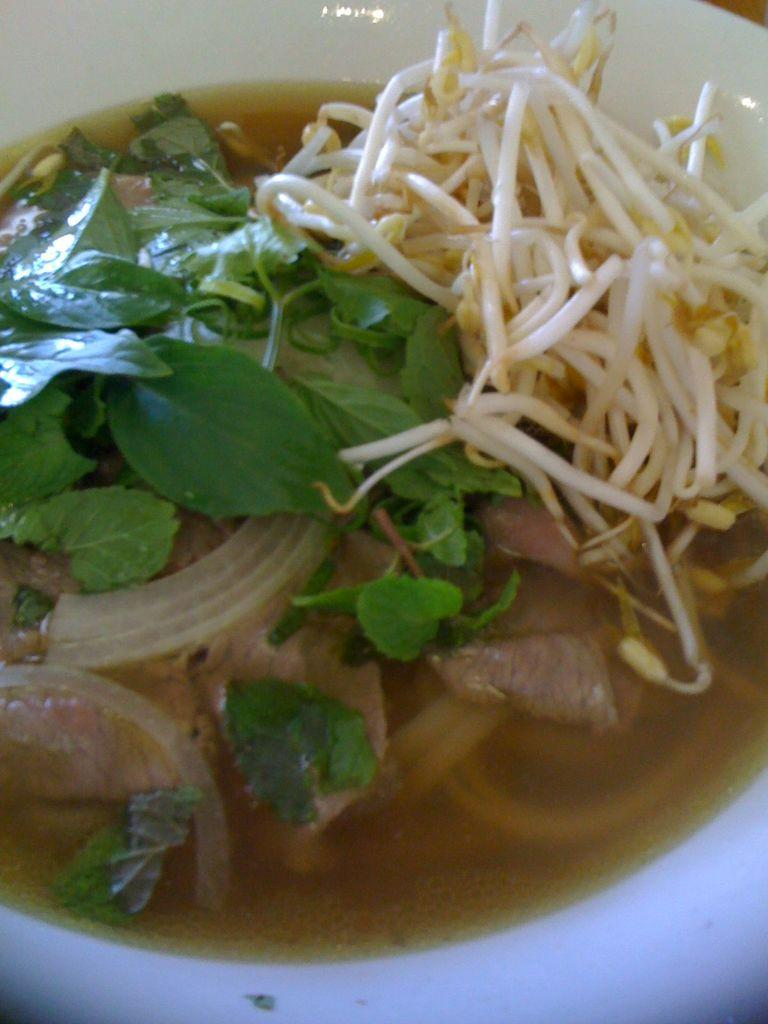What is the main subject of the image? There is a food item in the image. How many bones can be seen in the image? There are no bones present in the image; it only features a food item. 